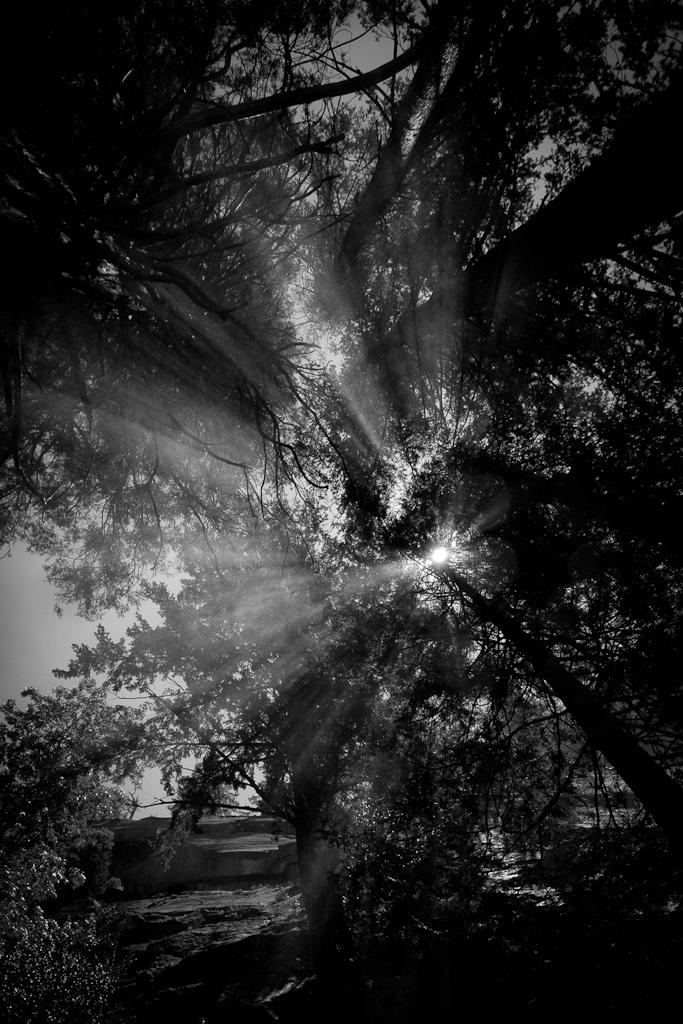What is the color scheme of the image? The image is black and white. What type of natural elements can be seen in the image? There are trees in the image. What celestial body is visible in the sky in the image? The sun is visible in the sky in the image. What type of jar is being used to capture the sun's rays in the image? There is no jar present in the image, and the sun's rays are not being captured. 